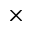<formula> <loc_0><loc_0><loc_500><loc_500>\times</formula> 